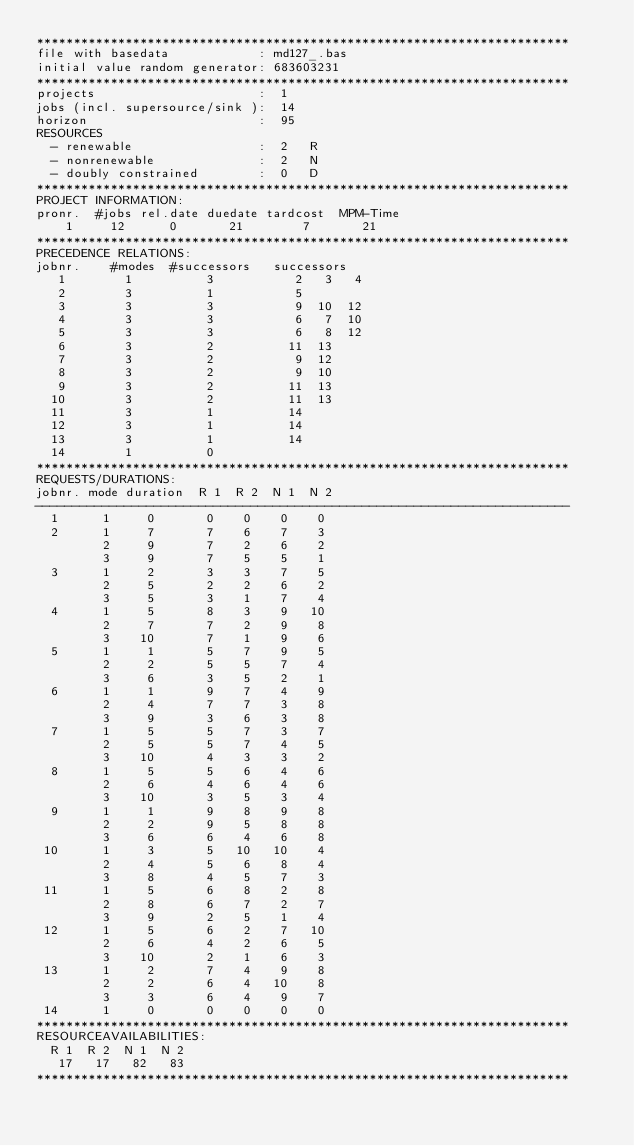<code> <loc_0><loc_0><loc_500><loc_500><_ObjectiveC_>************************************************************************
file with basedata            : md127_.bas
initial value random generator: 683603231
************************************************************************
projects                      :  1
jobs (incl. supersource/sink ):  14
horizon                       :  95
RESOURCES
  - renewable                 :  2   R
  - nonrenewable              :  2   N
  - doubly constrained        :  0   D
************************************************************************
PROJECT INFORMATION:
pronr.  #jobs rel.date duedate tardcost  MPM-Time
    1     12      0       21        7       21
************************************************************************
PRECEDENCE RELATIONS:
jobnr.    #modes  #successors   successors
   1        1          3           2   3   4
   2        3          1           5
   3        3          3           9  10  12
   4        3          3           6   7  10
   5        3          3           6   8  12
   6        3          2          11  13
   7        3          2           9  12
   8        3          2           9  10
   9        3          2          11  13
  10        3          2          11  13
  11        3          1          14
  12        3          1          14
  13        3          1          14
  14        1          0        
************************************************************************
REQUESTS/DURATIONS:
jobnr. mode duration  R 1  R 2  N 1  N 2
------------------------------------------------------------------------
  1      1     0       0    0    0    0
  2      1     7       7    6    7    3
         2     9       7    2    6    2
         3     9       7    5    5    1
  3      1     2       3    3    7    5
         2     5       2    2    6    2
         3     5       3    1    7    4
  4      1     5       8    3    9   10
         2     7       7    2    9    8
         3    10       7    1    9    6
  5      1     1       5    7    9    5
         2     2       5    5    7    4
         3     6       3    5    2    1
  6      1     1       9    7    4    9
         2     4       7    7    3    8
         3     9       3    6    3    8
  7      1     5       5    7    3    7
         2     5       5    7    4    5
         3    10       4    3    3    2
  8      1     5       5    6    4    6
         2     6       4    6    4    6
         3    10       3    5    3    4
  9      1     1       9    8    9    8
         2     2       9    5    8    8
         3     6       6    4    6    8
 10      1     3       5   10   10    4
         2     4       5    6    8    4
         3     8       4    5    7    3
 11      1     5       6    8    2    8
         2     8       6    7    2    7
         3     9       2    5    1    4
 12      1     5       6    2    7   10
         2     6       4    2    6    5
         3    10       2    1    6    3
 13      1     2       7    4    9    8
         2     2       6    4   10    8
         3     3       6    4    9    7
 14      1     0       0    0    0    0
************************************************************************
RESOURCEAVAILABILITIES:
  R 1  R 2  N 1  N 2
   17   17   82   83
************************************************************************
</code> 